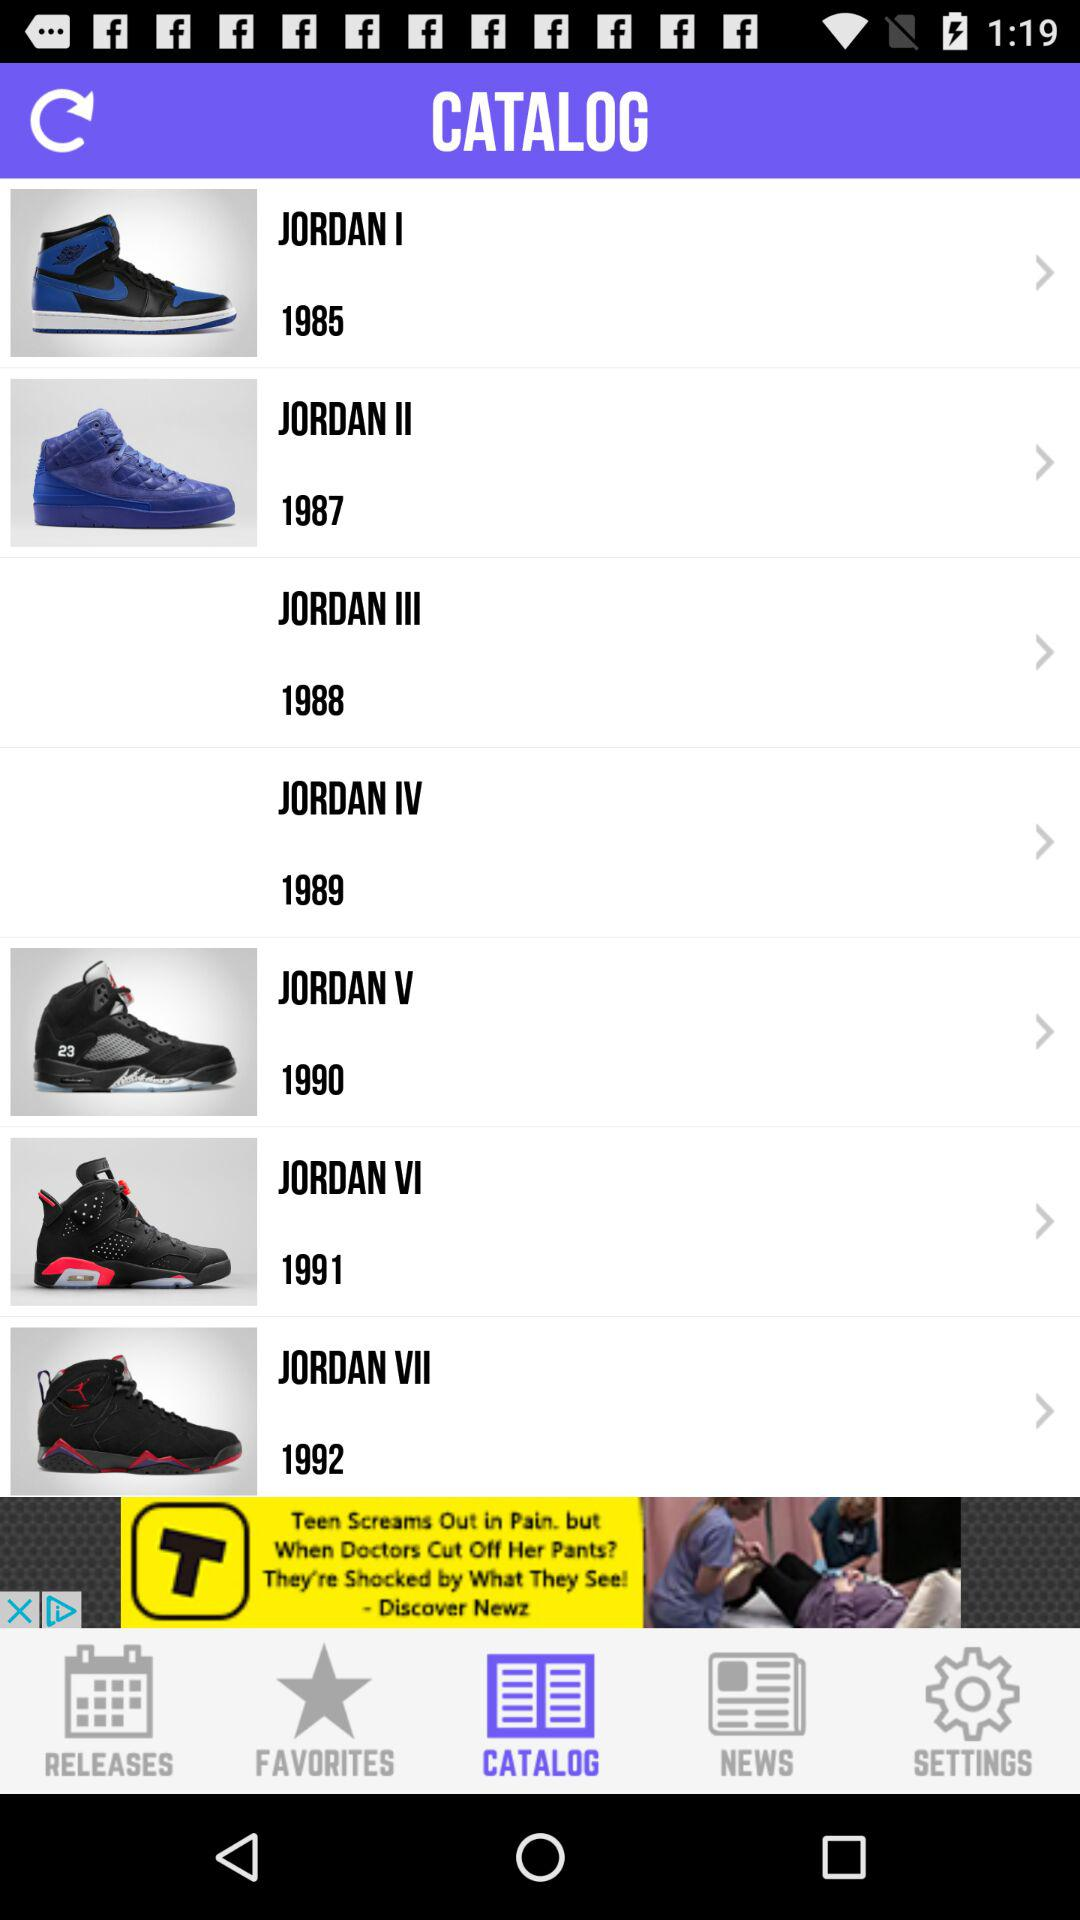Is Jordan I available in the catalog?
When the provided information is insufficient, respond with <no answer>. <no answer> 